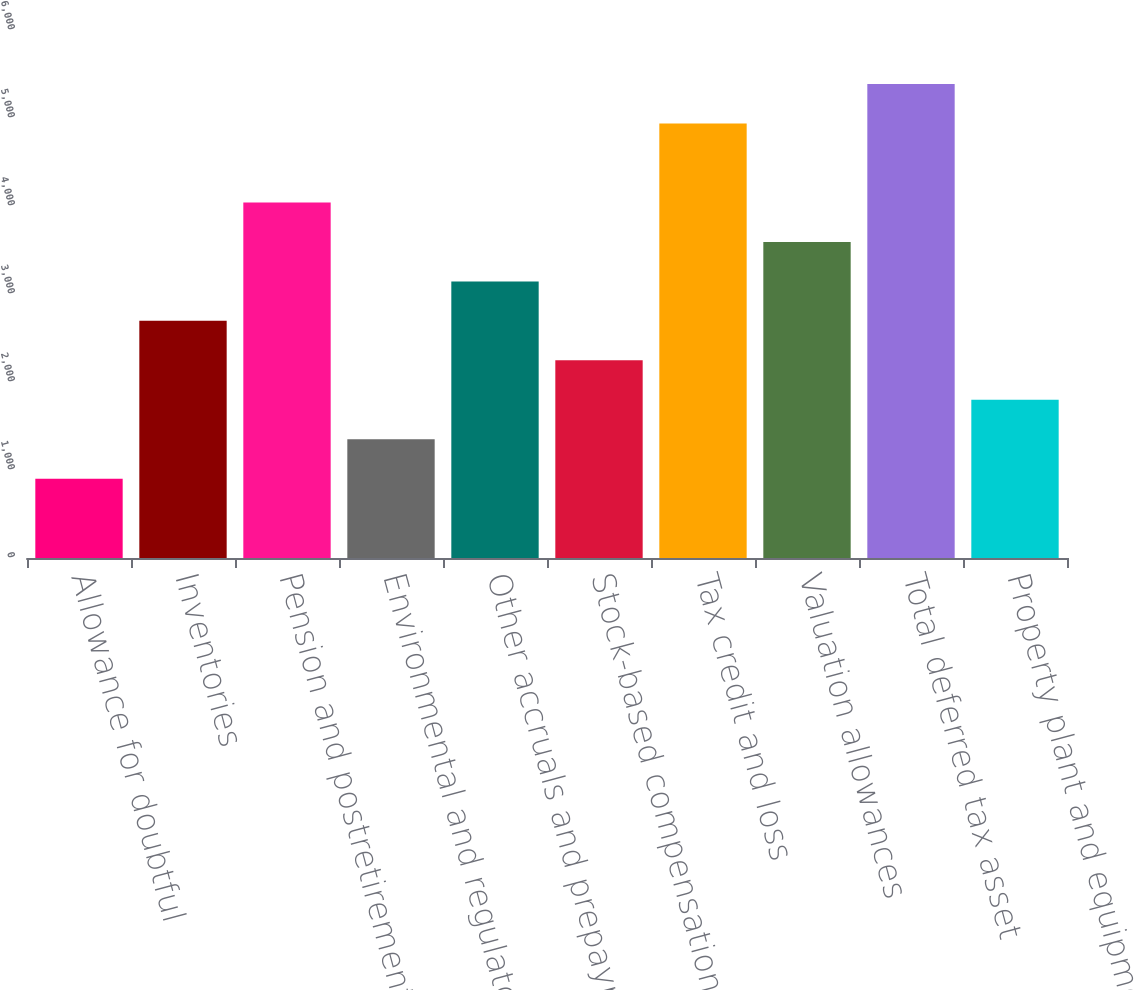Convert chart. <chart><loc_0><loc_0><loc_500><loc_500><bar_chart><fcel>Allowance for doubtful<fcel>Inventories<fcel>Pension and postretirement<fcel>Environmental and regulatory<fcel>Other accruals and prepayments<fcel>Stock-based compensation<fcel>Tax credit and loss<fcel>Valuation allowances<fcel>Total deferred tax asset<fcel>Property plant and equipment<nl><fcel>900.14<fcel>2694.62<fcel>4040.48<fcel>1348.76<fcel>3143.24<fcel>2246<fcel>4937.72<fcel>3591.86<fcel>5386.34<fcel>1797.38<nl></chart> 